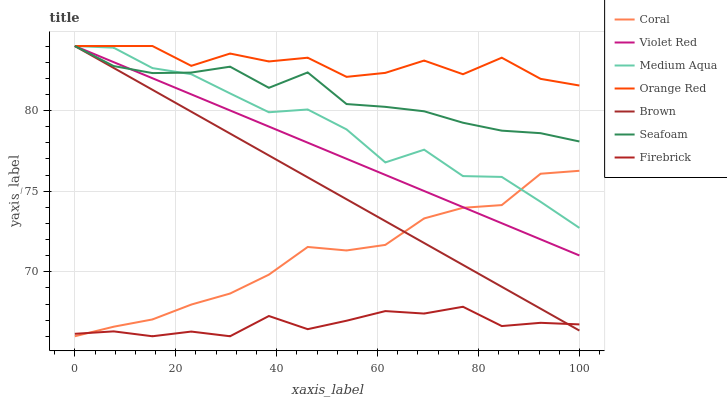Does Firebrick have the minimum area under the curve?
Answer yes or no. Yes. Does Orange Red have the maximum area under the curve?
Answer yes or no. Yes. Does Violet Red have the minimum area under the curve?
Answer yes or no. No. Does Violet Red have the maximum area under the curve?
Answer yes or no. No. Is Brown the smoothest?
Answer yes or no. Yes. Is Orange Red the roughest?
Answer yes or no. Yes. Is Violet Red the smoothest?
Answer yes or no. No. Is Violet Red the roughest?
Answer yes or no. No. Does Coral have the lowest value?
Answer yes or no. Yes. Does Violet Red have the lowest value?
Answer yes or no. No. Does Orange Red have the highest value?
Answer yes or no. Yes. Does Coral have the highest value?
Answer yes or no. No. Is Firebrick less than Seafoam?
Answer yes or no. Yes. Is Orange Red greater than Firebrick?
Answer yes or no. Yes. Does Brown intersect Orange Red?
Answer yes or no. Yes. Is Brown less than Orange Red?
Answer yes or no. No. Is Brown greater than Orange Red?
Answer yes or no. No. Does Firebrick intersect Seafoam?
Answer yes or no. No. 